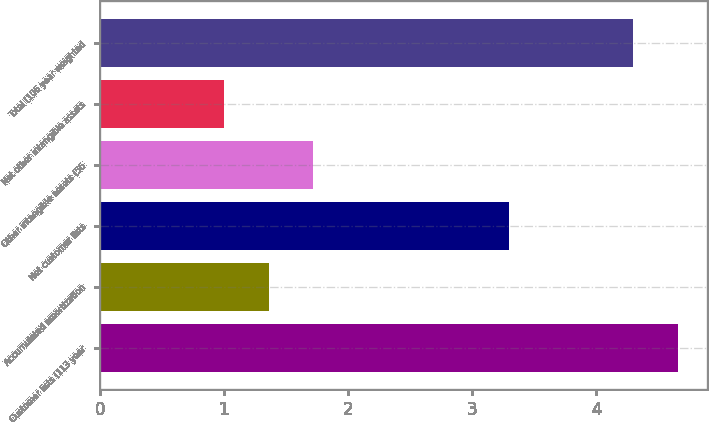Convert chart to OTSL. <chart><loc_0><loc_0><loc_500><loc_500><bar_chart><fcel>Customer lists (113 year<fcel>Accumulated amortization<fcel>Net customer lists<fcel>Other intangible assets (56<fcel>Net other intangible assets<fcel>Total (106 year weighted<nl><fcel>4.66<fcel>1.36<fcel>3.3<fcel>1.72<fcel>1<fcel>4.3<nl></chart> 